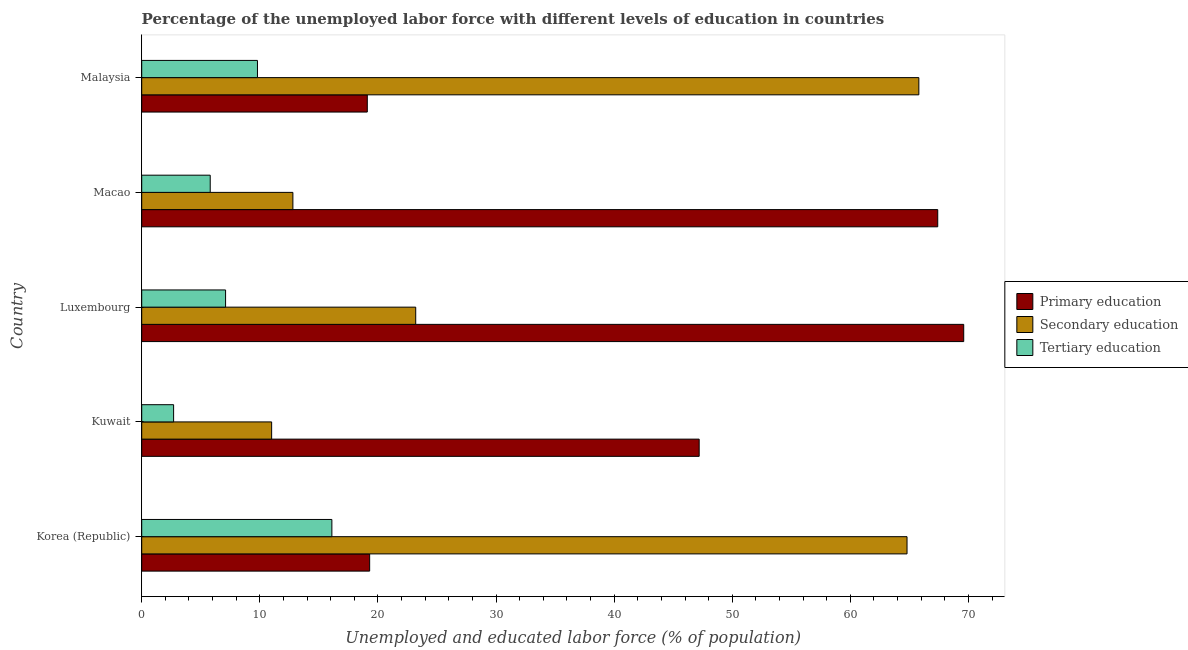How many different coloured bars are there?
Your answer should be very brief. 3. How many groups of bars are there?
Your answer should be very brief. 5. How many bars are there on the 2nd tick from the bottom?
Ensure brevity in your answer.  3. What is the label of the 4th group of bars from the top?
Make the answer very short. Kuwait. What is the percentage of labor force who received tertiary education in Kuwait?
Make the answer very short. 2.7. Across all countries, what is the maximum percentage of labor force who received tertiary education?
Ensure brevity in your answer.  16.1. Across all countries, what is the minimum percentage of labor force who received primary education?
Offer a very short reply. 19.1. In which country was the percentage of labor force who received primary education maximum?
Keep it short and to the point. Luxembourg. In which country was the percentage of labor force who received secondary education minimum?
Ensure brevity in your answer.  Kuwait. What is the total percentage of labor force who received primary education in the graph?
Your answer should be compact. 222.6. What is the difference between the percentage of labor force who received primary education in Kuwait and that in Luxembourg?
Ensure brevity in your answer.  -22.4. What is the difference between the percentage of labor force who received tertiary education in Kuwait and the percentage of labor force who received primary education in Korea (Republic)?
Offer a terse response. -16.6. What is the difference between the percentage of labor force who received tertiary education and percentage of labor force who received primary education in Macao?
Make the answer very short. -61.6. In how many countries, is the percentage of labor force who received secondary education greater than 64 %?
Keep it short and to the point. 2. What is the ratio of the percentage of labor force who received tertiary education in Kuwait to that in Luxembourg?
Provide a short and direct response. 0.38. Is the difference between the percentage of labor force who received secondary education in Macao and Malaysia greater than the difference between the percentage of labor force who received tertiary education in Macao and Malaysia?
Provide a short and direct response. No. What is the difference between the highest and the second highest percentage of labor force who received secondary education?
Your response must be concise. 1. What is the difference between the highest and the lowest percentage of labor force who received primary education?
Offer a very short reply. 50.5. What does the 3rd bar from the top in Macao represents?
Your answer should be compact. Primary education. How many bars are there?
Offer a very short reply. 15. Are all the bars in the graph horizontal?
Provide a succinct answer. Yes. How many countries are there in the graph?
Your answer should be very brief. 5. Are the values on the major ticks of X-axis written in scientific E-notation?
Offer a terse response. No. How many legend labels are there?
Your answer should be very brief. 3. What is the title of the graph?
Your response must be concise. Percentage of the unemployed labor force with different levels of education in countries. Does "Primary education" appear as one of the legend labels in the graph?
Keep it short and to the point. Yes. What is the label or title of the X-axis?
Provide a short and direct response. Unemployed and educated labor force (% of population). What is the Unemployed and educated labor force (% of population) of Primary education in Korea (Republic)?
Make the answer very short. 19.3. What is the Unemployed and educated labor force (% of population) in Secondary education in Korea (Republic)?
Make the answer very short. 64.8. What is the Unemployed and educated labor force (% of population) of Tertiary education in Korea (Republic)?
Offer a terse response. 16.1. What is the Unemployed and educated labor force (% of population) in Primary education in Kuwait?
Your answer should be very brief. 47.2. What is the Unemployed and educated labor force (% of population) in Tertiary education in Kuwait?
Offer a terse response. 2.7. What is the Unemployed and educated labor force (% of population) of Primary education in Luxembourg?
Your answer should be compact. 69.6. What is the Unemployed and educated labor force (% of population) in Secondary education in Luxembourg?
Ensure brevity in your answer.  23.2. What is the Unemployed and educated labor force (% of population) in Tertiary education in Luxembourg?
Your answer should be compact. 7.1. What is the Unemployed and educated labor force (% of population) in Primary education in Macao?
Keep it short and to the point. 67.4. What is the Unemployed and educated labor force (% of population) in Secondary education in Macao?
Your answer should be compact. 12.8. What is the Unemployed and educated labor force (% of population) in Tertiary education in Macao?
Give a very brief answer. 5.8. What is the Unemployed and educated labor force (% of population) in Primary education in Malaysia?
Your response must be concise. 19.1. What is the Unemployed and educated labor force (% of population) of Secondary education in Malaysia?
Your answer should be compact. 65.8. What is the Unemployed and educated labor force (% of population) of Tertiary education in Malaysia?
Your answer should be compact. 9.8. Across all countries, what is the maximum Unemployed and educated labor force (% of population) in Primary education?
Offer a terse response. 69.6. Across all countries, what is the maximum Unemployed and educated labor force (% of population) in Secondary education?
Offer a very short reply. 65.8. Across all countries, what is the maximum Unemployed and educated labor force (% of population) in Tertiary education?
Your response must be concise. 16.1. Across all countries, what is the minimum Unemployed and educated labor force (% of population) in Primary education?
Your response must be concise. 19.1. Across all countries, what is the minimum Unemployed and educated labor force (% of population) of Secondary education?
Your answer should be compact. 11. Across all countries, what is the minimum Unemployed and educated labor force (% of population) in Tertiary education?
Your answer should be compact. 2.7. What is the total Unemployed and educated labor force (% of population) of Primary education in the graph?
Make the answer very short. 222.6. What is the total Unemployed and educated labor force (% of population) in Secondary education in the graph?
Your answer should be compact. 177.6. What is the total Unemployed and educated labor force (% of population) of Tertiary education in the graph?
Offer a very short reply. 41.5. What is the difference between the Unemployed and educated labor force (% of population) in Primary education in Korea (Republic) and that in Kuwait?
Your answer should be very brief. -27.9. What is the difference between the Unemployed and educated labor force (% of population) of Secondary education in Korea (Republic) and that in Kuwait?
Your response must be concise. 53.8. What is the difference between the Unemployed and educated labor force (% of population) in Tertiary education in Korea (Republic) and that in Kuwait?
Provide a succinct answer. 13.4. What is the difference between the Unemployed and educated labor force (% of population) of Primary education in Korea (Republic) and that in Luxembourg?
Your response must be concise. -50.3. What is the difference between the Unemployed and educated labor force (% of population) in Secondary education in Korea (Republic) and that in Luxembourg?
Provide a succinct answer. 41.6. What is the difference between the Unemployed and educated labor force (% of population) in Tertiary education in Korea (Republic) and that in Luxembourg?
Provide a short and direct response. 9. What is the difference between the Unemployed and educated labor force (% of population) in Primary education in Korea (Republic) and that in Macao?
Offer a very short reply. -48.1. What is the difference between the Unemployed and educated labor force (% of population) of Secondary education in Korea (Republic) and that in Macao?
Provide a short and direct response. 52. What is the difference between the Unemployed and educated labor force (% of population) in Tertiary education in Korea (Republic) and that in Malaysia?
Your answer should be very brief. 6.3. What is the difference between the Unemployed and educated labor force (% of population) in Primary education in Kuwait and that in Luxembourg?
Make the answer very short. -22.4. What is the difference between the Unemployed and educated labor force (% of population) of Secondary education in Kuwait and that in Luxembourg?
Offer a terse response. -12.2. What is the difference between the Unemployed and educated labor force (% of population) of Primary education in Kuwait and that in Macao?
Keep it short and to the point. -20.2. What is the difference between the Unemployed and educated labor force (% of population) in Primary education in Kuwait and that in Malaysia?
Your answer should be very brief. 28.1. What is the difference between the Unemployed and educated labor force (% of population) of Secondary education in Kuwait and that in Malaysia?
Your answer should be compact. -54.8. What is the difference between the Unemployed and educated labor force (% of population) in Secondary education in Luxembourg and that in Macao?
Make the answer very short. 10.4. What is the difference between the Unemployed and educated labor force (% of population) in Tertiary education in Luxembourg and that in Macao?
Give a very brief answer. 1.3. What is the difference between the Unemployed and educated labor force (% of population) of Primary education in Luxembourg and that in Malaysia?
Your answer should be compact. 50.5. What is the difference between the Unemployed and educated labor force (% of population) of Secondary education in Luxembourg and that in Malaysia?
Offer a terse response. -42.6. What is the difference between the Unemployed and educated labor force (% of population) in Primary education in Macao and that in Malaysia?
Ensure brevity in your answer.  48.3. What is the difference between the Unemployed and educated labor force (% of population) in Secondary education in Macao and that in Malaysia?
Offer a very short reply. -53. What is the difference between the Unemployed and educated labor force (% of population) of Primary education in Korea (Republic) and the Unemployed and educated labor force (% of population) of Secondary education in Kuwait?
Provide a short and direct response. 8.3. What is the difference between the Unemployed and educated labor force (% of population) of Primary education in Korea (Republic) and the Unemployed and educated labor force (% of population) of Tertiary education in Kuwait?
Offer a very short reply. 16.6. What is the difference between the Unemployed and educated labor force (% of population) of Secondary education in Korea (Republic) and the Unemployed and educated labor force (% of population) of Tertiary education in Kuwait?
Your answer should be compact. 62.1. What is the difference between the Unemployed and educated labor force (% of population) in Secondary education in Korea (Republic) and the Unemployed and educated labor force (% of population) in Tertiary education in Luxembourg?
Give a very brief answer. 57.7. What is the difference between the Unemployed and educated labor force (% of population) in Primary education in Korea (Republic) and the Unemployed and educated labor force (% of population) in Secondary education in Malaysia?
Provide a short and direct response. -46.5. What is the difference between the Unemployed and educated labor force (% of population) in Secondary education in Korea (Republic) and the Unemployed and educated labor force (% of population) in Tertiary education in Malaysia?
Offer a very short reply. 55. What is the difference between the Unemployed and educated labor force (% of population) in Primary education in Kuwait and the Unemployed and educated labor force (% of population) in Secondary education in Luxembourg?
Offer a terse response. 24. What is the difference between the Unemployed and educated labor force (% of population) in Primary education in Kuwait and the Unemployed and educated labor force (% of population) in Tertiary education in Luxembourg?
Ensure brevity in your answer.  40.1. What is the difference between the Unemployed and educated labor force (% of population) of Secondary education in Kuwait and the Unemployed and educated labor force (% of population) of Tertiary education in Luxembourg?
Provide a succinct answer. 3.9. What is the difference between the Unemployed and educated labor force (% of population) in Primary education in Kuwait and the Unemployed and educated labor force (% of population) in Secondary education in Macao?
Your response must be concise. 34.4. What is the difference between the Unemployed and educated labor force (% of population) of Primary education in Kuwait and the Unemployed and educated labor force (% of population) of Tertiary education in Macao?
Make the answer very short. 41.4. What is the difference between the Unemployed and educated labor force (% of population) of Primary education in Kuwait and the Unemployed and educated labor force (% of population) of Secondary education in Malaysia?
Provide a short and direct response. -18.6. What is the difference between the Unemployed and educated labor force (% of population) in Primary education in Kuwait and the Unemployed and educated labor force (% of population) in Tertiary education in Malaysia?
Offer a terse response. 37.4. What is the difference between the Unemployed and educated labor force (% of population) of Primary education in Luxembourg and the Unemployed and educated labor force (% of population) of Secondary education in Macao?
Make the answer very short. 56.8. What is the difference between the Unemployed and educated labor force (% of population) in Primary education in Luxembourg and the Unemployed and educated labor force (% of population) in Tertiary education in Macao?
Your answer should be compact. 63.8. What is the difference between the Unemployed and educated labor force (% of population) in Secondary education in Luxembourg and the Unemployed and educated labor force (% of population) in Tertiary education in Macao?
Make the answer very short. 17.4. What is the difference between the Unemployed and educated labor force (% of population) in Primary education in Luxembourg and the Unemployed and educated labor force (% of population) in Tertiary education in Malaysia?
Give a very brief answer. 59.8. What is the difference between the Unemployed and educated labor force (% of population) of Primary education in Macao and the Unemployed and educated labor force (% of population) of Tertiary education in Malaysia?
Make the answer very short. 57.6. What is the difference between the Unemployed and educated labor force (% of population) of Secondary education in Macao and the Unemployed and educated labor force (% of population) of Tertiary education in Malaysia?
Offer a terse response. 3. What is the average Unemployed and educated labor force (% of population) of Primary education per country?
Keep it short and to the point. 44.52. What is the average Unemployed and educated labor force (% of population) of Secondary education per country?
Offer a terse response. 35.52. What is the difference between the Unemployed and educated labor force (% of population) in Primary education and Unemployed and educated labor force (% of population) in Secondary education in Korea (Republic)?
Your answer should be compact. -45.5. What is the difference between the Unemployed and educated labor force (% of population) in Primary education and Unemployed and educated labor force (% of population) in Tertiary education in Korea (Republic)?
Provide a short and direct response. 3.2. What is the difference between the Unemployed and educated labor force (% of population) of Secondary education and Unemployed and educated labor force (% of population) of Tertiary education in Korea (Republic)?
Offer a very short reply. 48.7. What is the difference between the Unemployed and educated labor force (% of population) in Primary education and Unemployed and educated labor force (% of population) in Secondary education in Kuwait?
Your answer should be very brief. 36.2. What is the difference between the Unemployed and educated labor force (% of population) of Primary education and Unemployed and educated labor force (% of population) of Tertiary education in Kuwait?
Give a very brief answer. 44.5. What is the difference between the Unemployed and educated labor force (% of population) of Secondary education and Unemployed and educated labor force (% of population) of Tertiary education in Kuwait?
Your response must be concise. 8.3. What is the difference between the Unemployed and educated labor force (% of population) in Primary education and Unemployed and educated labor force (% of population) in Secondary education in Luxembourg?
Give a very brief answer. 46.4. What is the difference between the Unemployed and educated labor force (% of population) in Primary education and Unemployed and educated labor force (% of population) in Tertiary education in Luxembourg?
Give a very brief answer. 62.5. What is the difference between the Unemployed and educated labor force (% of population) in Primary education and Unemployed and educated labor force (% of population) in Secondary education in Macao?
Offer a very short reply. 54.6. What is the difference between the Unemployed and educated labor force (% of population) in Primary education and Unemployed and educated labor force (% of population) in Tertiary education in Macao?
Your response must be concise. 61.6. What is the difference between the Unemployed and educated labor force (% of population) of Secondary education and Unemployed and educated labor force (% of population) of Tertiary education in Macao?
Ensure brevity in your answer.  7. What is the difference between the Unemployed and educated labor force (% of population) in Primary education and Unemployed and educated labor force (% of population) in Secondary education in Malaysia?
Provide a succinct answer. -46.7. What is the difference between the Unemployed and educated labor force (% of population) in Primary education and Unemployed and educated labor force (% of population) in Tertiary education in Malaysia?
Offer a very short reply. 9.3. What is the difference between the Unemployed and educated labor force (% of population) of Secondary education and Unemployed and educated labor force (% of population) of Tertiary education in Malaysia?
Your response must be concise. 56. What is the ratio of the Unemployed and educated labor force (% of population) of Primary education in Korea (Republic) to that in Kuwait?
Make the answer very short. 0.41. What is the ratio of the Unemployed and educated labor force (% of population) of Secondary education in Korea (Republic) to that in Kuwait?
Your answer should be compact. 5.89. What is the ratio of the Unemployed and educated labor force (% of population) of Tertiary education in Korea (Republic) to that in Kuwait?
Keep it short and to the point. 5.96. What is the ratio of the Unemployed and educated labor force (% of population) in Primary education in Korea (Republic) to that in Luxembourg?
Keep it short and to the point. 0.28. What is the ratio of the Unemployed and educated labor force (% of population) in Secondary education in Korea (Republic) to that in Luxembourg?
Your answer should be very brief. 2.79. What is the ratio of the Unemployed and educated labor force (% of population) in Tertiary education in Korea (Republic) to that in Luxembourg?
Offer a very short reply. 2.27. What is the ratio of the Unemployed and educated labor force (% of population) in Primary education in Korea (Republic) to that in Macao?
Ensure brevity in your answer.  0.29. What is the ratio of the Unemployed and educated labor force (% of population) in Secondary education in Korea (Republic) to that in Macao?
Offer a very short reply. 5.06. What is the ratio of the Unemployed and educated labor force (% of population) of Tertiary education in Korea (Republic) to that in Macao?
Your response must be concise. 2.78. What is the ratio of the Unemployed and educated labor force (% of population) of Primary education in Korea (Republic) to that in Malaysia?
Make the answer very short. 1.01. What is the ratio of the Unemployed and educated labor force (% of population) of Tertiary education in Korea (Republic) to that in Malaysia?
Make the answer very short. 1.64. What is the ratio of the Unemployed and educated labor force (% of population) of Primary education in Kuwait to that in Luxembourg?
Keep it short and to the point. 0.68. What is the ratio of the Unemployed and educated labor force (% of population) in Secondary education in Kuwait to that in Luxembourg?
Offer a terse response. 0.47. What is the ratio of the Unemployed and educated labor force (% of population) in Tertiary education in Kuwait to that in Luxembourg?
Ensure brevity in your answer.  0.38. What is the ratio of the Unemployed and educated labor force (% of population) in Primary education in Kuwait to that in Macao?
Keep it short and to the point. 0.7. What is the ratio of the Unemployed and educated labor force (% of population) in Secondary education in Kuwait to that in Macao?
Provide a succinct answer. 0.86. What is the ratio of the Unemployed and educated labor force (% of population) of Tertiary education in Kuwait to that in Macao?
Provide a succinct answer. 0.47. What is the ratio of the Unemployed and educated labor force (% of population) of Primary education in Kuwait to that in Malaysia?
Provide a succinct answer. 2.47. What is the ratio of the Unemployed and educated labor force (% of population) in Secondary education in Kuwait to that in Malaysia?
Offer a terse response. 0.17. What is the ratio of the Unemployed and educated labor force (% of population) of Tertiary education in Kuwait to that in Malaysia?
Keep it short and to the point. 0.28. What is the ratio of the Unemployed and educated labor force (% of population) of Primary education in Luxembourg to that in Macao?
Your answer should be compact. 1.03. What is the ratio of the Unemployed and educated labor force (% of population) of Secondary education in Luxembourg to that in Macao?
Offer a terse response. 1.81. What is the ratio of the Unemployed and educated labor force (% of population) in Tertiary education in Luxembourg to that in Macao?
Provide a short and direct response. 1.22. What is the ratio of the Unemployed and educated labor force (% of population) in Primary education in Luxembourg to that in Malaysia?
Give a very brief answer. 3.64. What is the ratio of the Unemployed and educated labor force (% of population) of Secondary education in Luxembourg to that in Malaysia?
Offer a very short reply. 0.35. What is the ratio of the Unemployed and educated labor force (% of population) in Tertiary education in Luxembourg to that in Malaysia?
Offer a very short reply. 0.72. What is the ratio of the Unemployed and educated labor force (% of population) in Primary education in Macao to that in Malaysia?
Your answer should be very brief. 3.53. What is the ratio of the Unemployed and educated labor force (% of population) of Secondary education in Macao to that in Malaysia?
Your response must be concise. 0.19. What is the ratio of the Unemployed and educated labor force (% of population) in Tertiary education in Macao to that in Malaysia?
Ensure brevity in your answer.  0.59. What is the difference between the highest and the second highest Unemployed and educated labor force (% of population) in Secondary education?
Keep it short and to the point. 1. What is the difference between the highest and the second highest Unemployed and educated labor force (% of population) of Tertiary education?
Your answer should be compact. 6.3. What is the difference between the highest and the lowest Unemployed and educated labor force (% of population) of Primary education?
Your answer should be compact. 50.5. What is the difference between the highest and the lowest Unemployed and educated labor force (% of population) in Secondary education?
Ensure brevity in your answer.  54.8. What is the difference between the highest and the lowest Unemployed and educated labor force (% of population) of Tertiary education?
Make the answer very short. 13.4. 